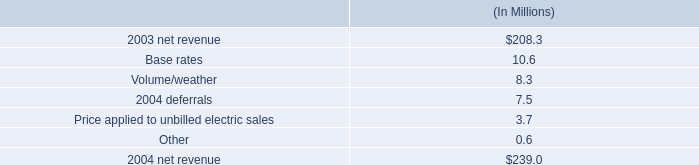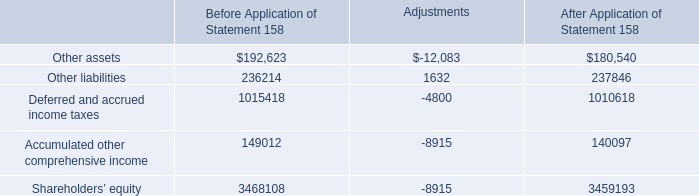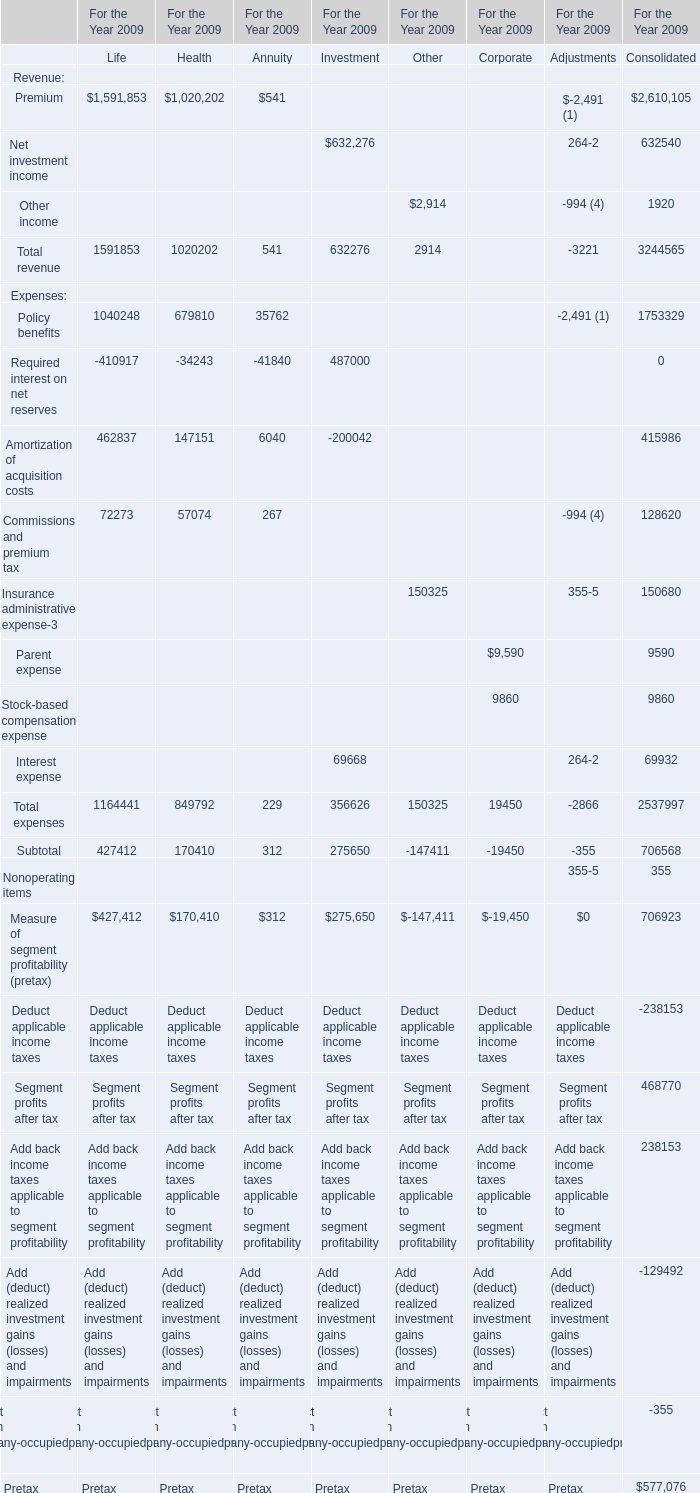What's the sum of Other assets of Adjustments, and Net investment income of For the Year 2009 Investment ? 
Computations: (12083.0 + 632276.0)
Answer: 644359.0. 